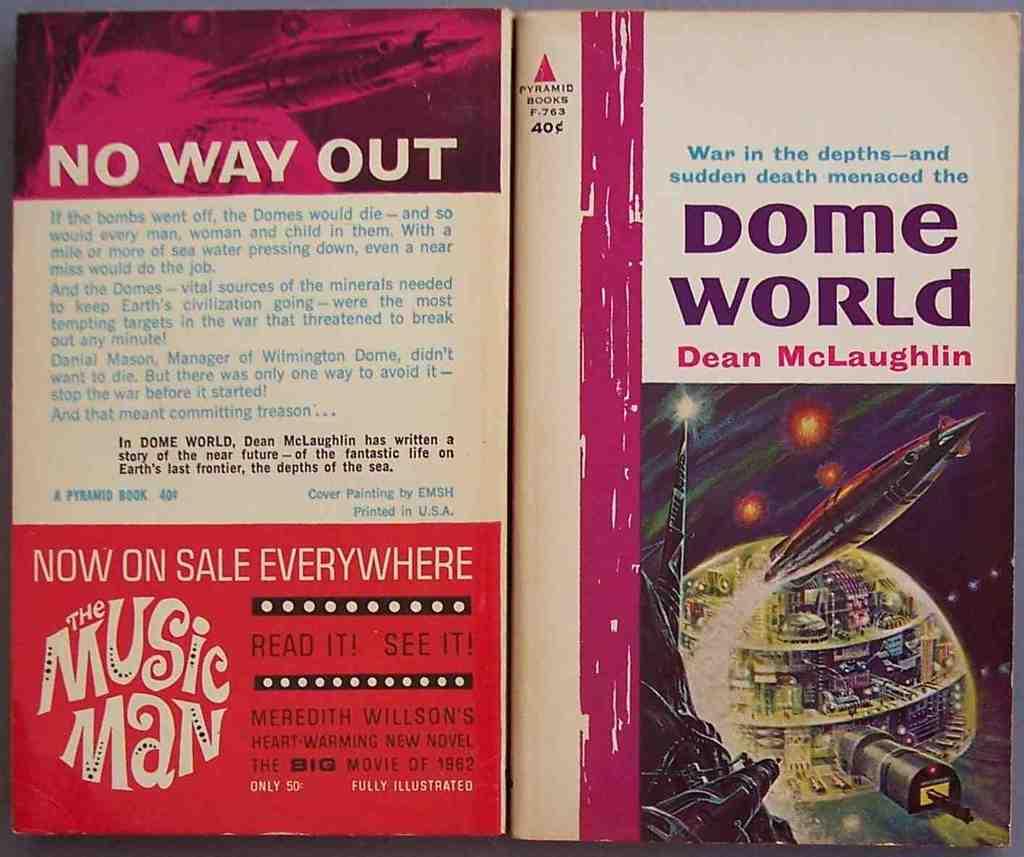Who wrote this book?
Ensure brevity in your answer.  Dean mclaughlin. What is the title of the book?
Your answer should be very brief. Dome world. 